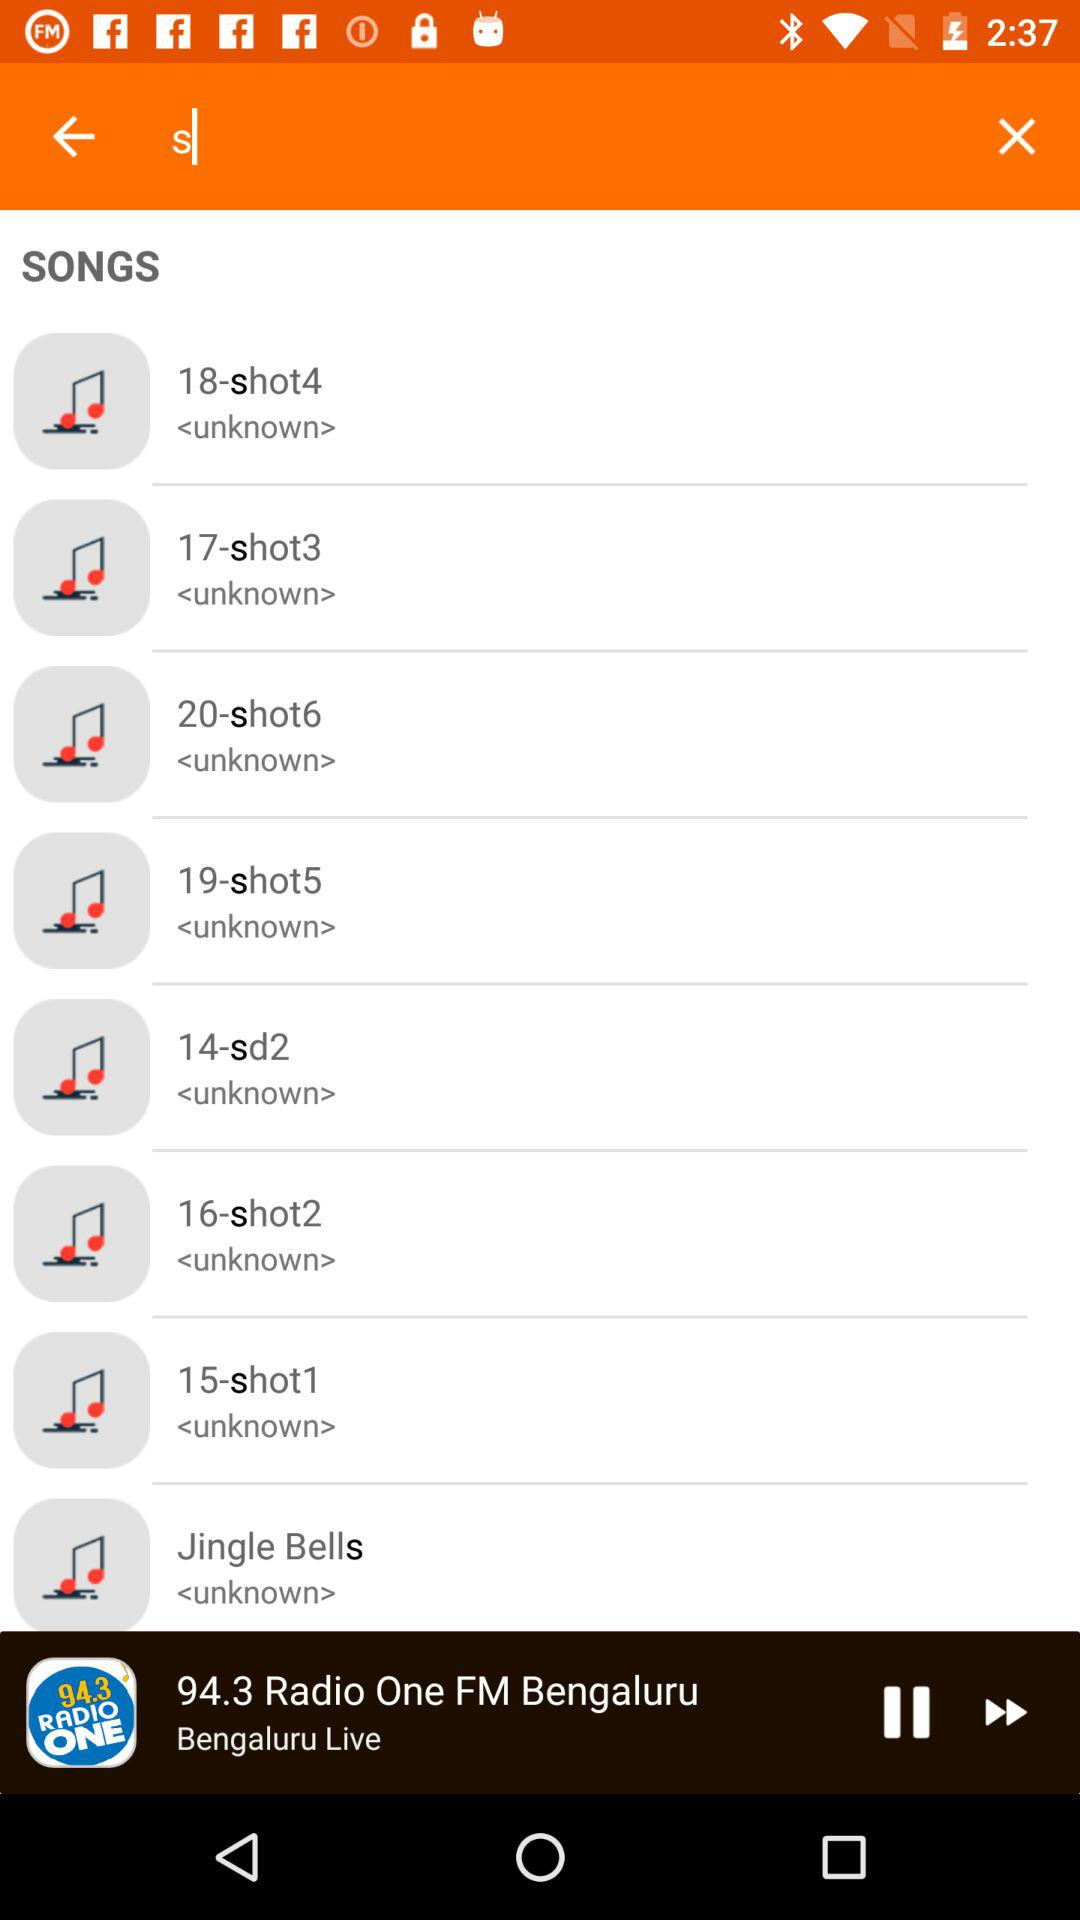Which audio is currently playing? The audio currently playing is "94.3 Radio One FM Bengaluru". 